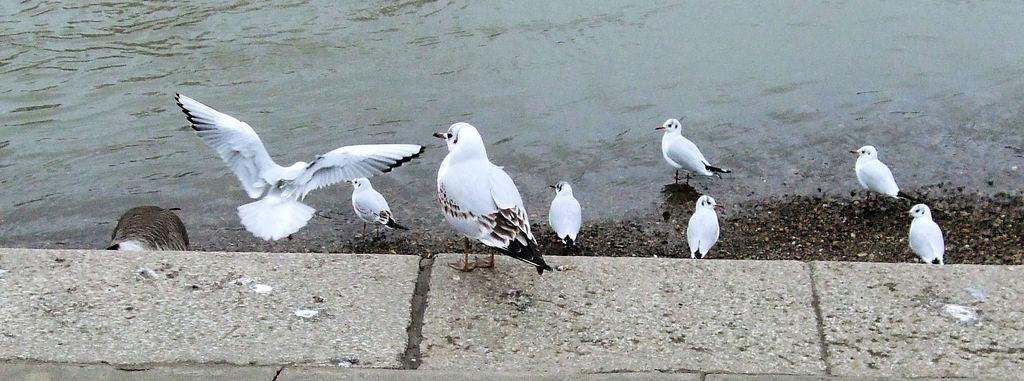What type of animals can be seen in the image? Birds can be seen in the image. What is the primary element in which the birds are situated? The birds are situated in water. What type of bulb is being used by the birds to light up the area in the image? There is no bulb present in the image, as it features birds in the water. 